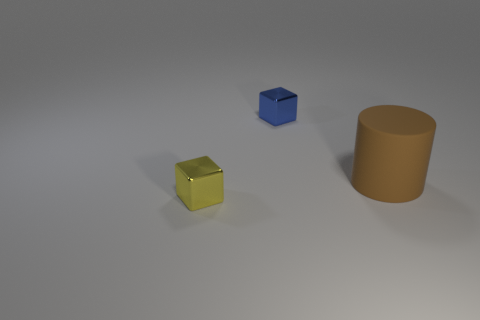There is a metallic cube that is the same size as the yellow thing; what is its color?
Provide a short and direct response. Blue. Are there any other cylinders that have the same color as the matte cylinder?
Give a very brief answer. No. Is there a tiny purple matte cylinder?
Your answer should be very brief. No. Are the blue object on the left side of the large brown rubber cylinder and the big cylinder made of the same material?
Your response must be concise. No. How many other cylinders are the same size as the rubber cylinder?
Offer a terse response. 0. Is the number of tiny yellow shiny cubes that are behind the tiny yellow object the same as the number of large gray rubber cylinders?
Your response must be concise. Yes. How many things are both in front of the tiny blue thing and left of the large matte thing?
Ensure brevity in your answer.  1. There is a cube that is the same material as the tiny yellow thing; what size is it?
Give a very brief answer. Small. How many small blue things have the same shape as the small yellow thing?
Your answer should be very brief. 1. Is the number of blue things that are in front of the blue block greater than the number of big rubber cylinders?
Offer a very short reply. No. 